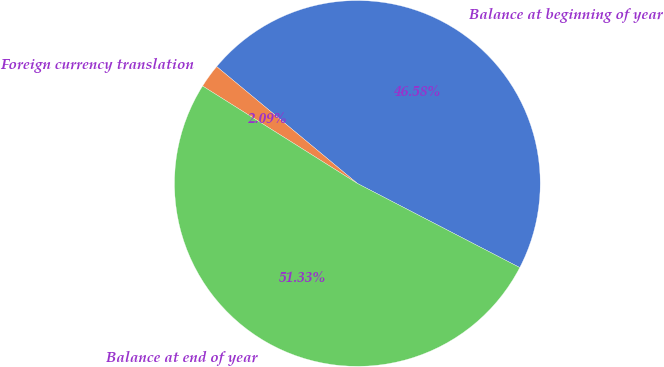Convert chart. <chart><loc_0><loc_0><loc_500><loc_500><pie_chart><fcel>Balance at beginning of year<fcel>Foreign currency translation<fcel>Balance at end of year<nl><fcel>46.58%<fcel>2.09%<fcel>51.34%<nl></chart> 